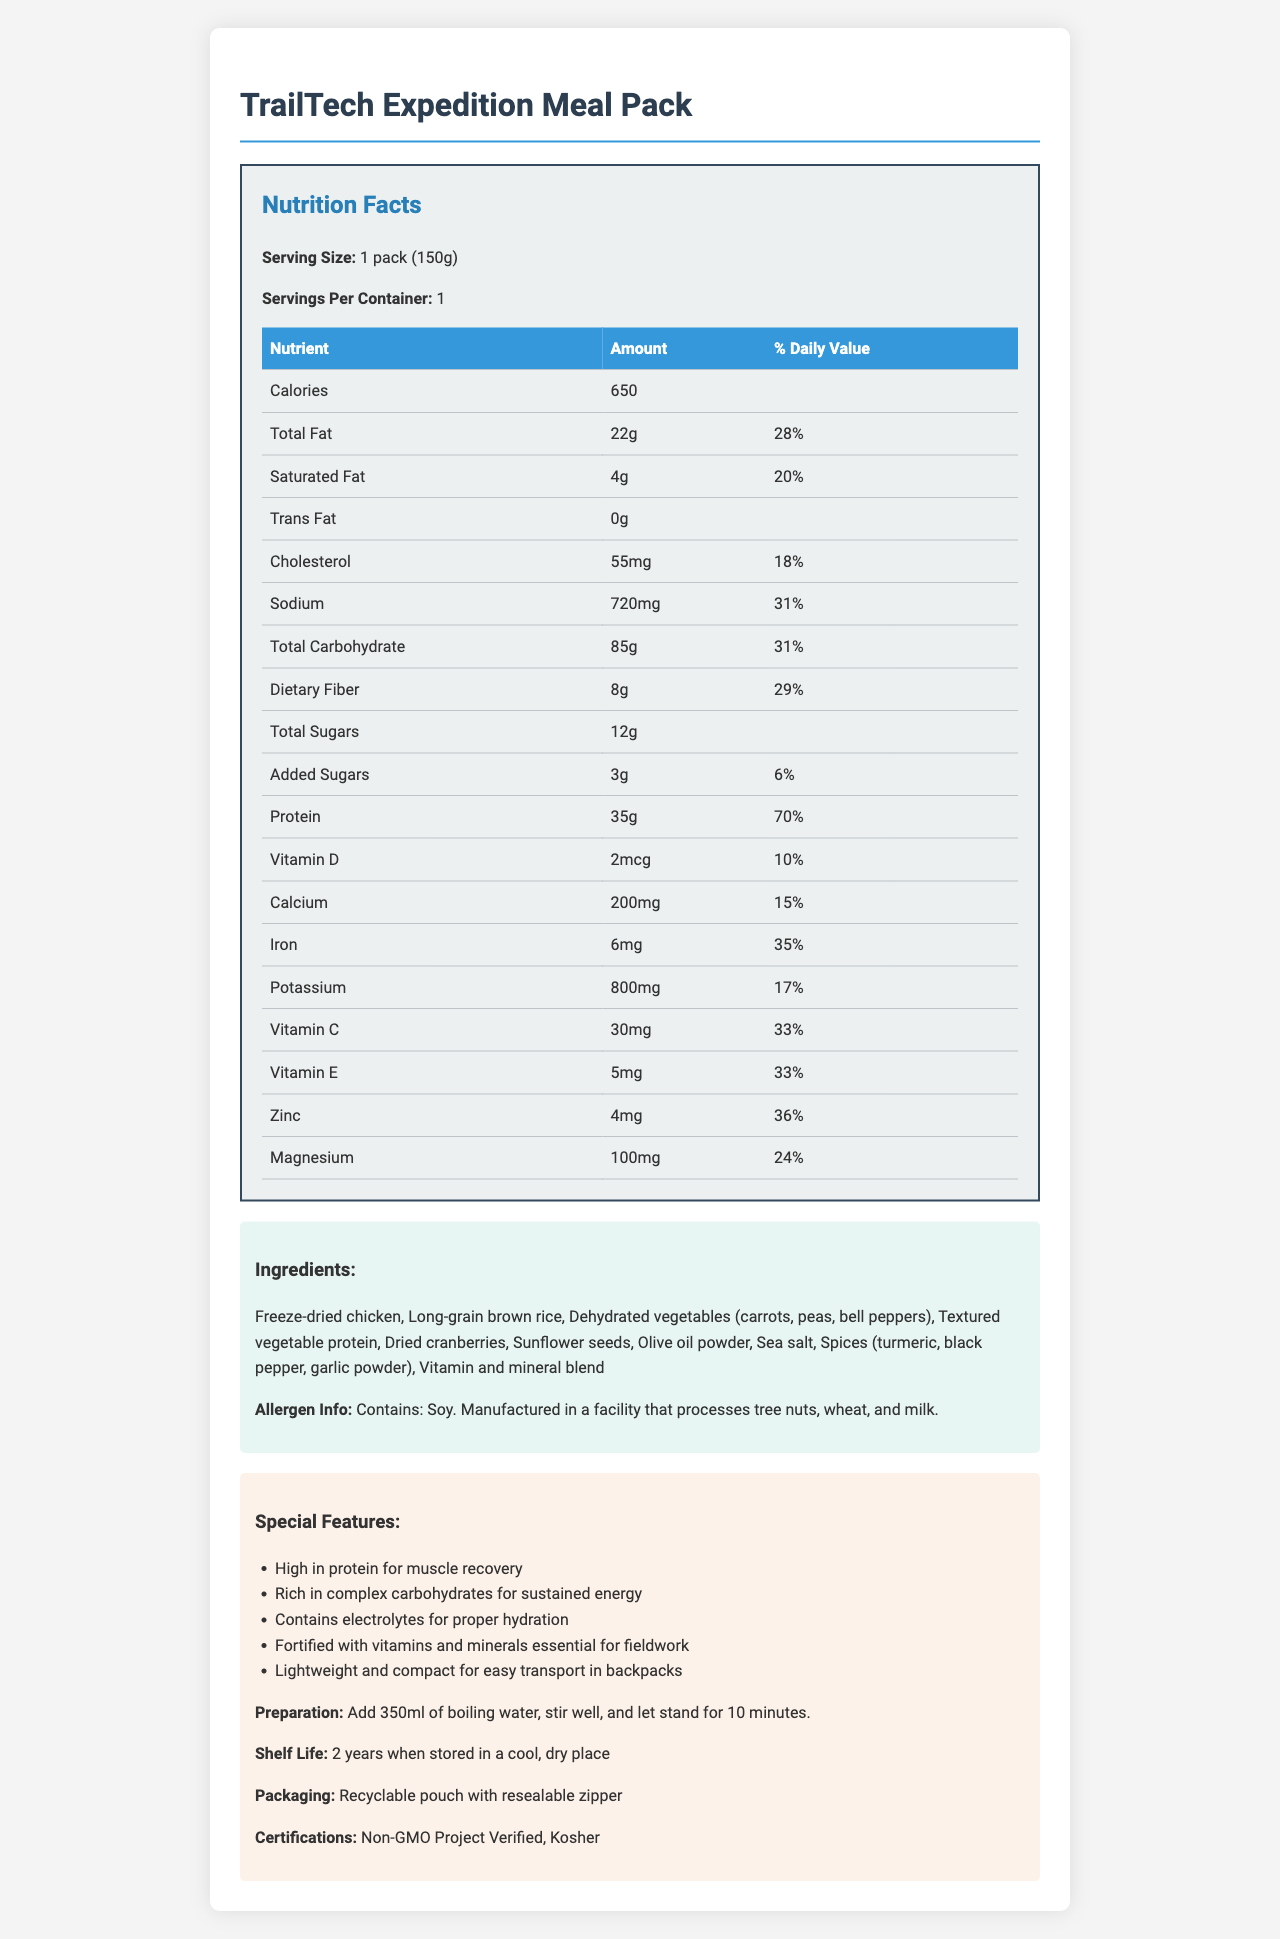what is the serving size of the TrailTech Expedition Meal Pack? The serving size is listed as "1 pack (150g)".
Answer: 1 pack (150g) how much protein does the meal pack provide? According to the nutrition facts, the meal pack contains 35 grams of protein.
Answer: 35g what percentage of daily value for sodium does the meal pack provide? The nutritional label indicates that sodium provides 31% of the daily value.
Answer: 31% what are the main ingredients of the TrailTech Expedition Meal Pack? These ingredients are listed under the ingredients section in the document.
Answer: Freeze-dried chicken, Long-grain brown rice, Dehydrated vegetables (carrots, peas, bell peppers), Textured vegetable protein, Dried cranberries, Sunflower seeds, Olive oil powder, Sea salt, Spices (turmeric, black pepper, garlic powder), Vitamin and mineral blend what is the preparation method for the meal pack? The preparation instructions are provided in the special features section.
Answer: Add 350ml of boiling water, stir well, and let stand for 10 minutes. where is the meal pack manufactured? The document does not provide any information about the manufacturing location.
Answer: Cannot be determined which of the following is a special feature of the meal pack? A. Organic ingredients B. High in protein for muscle recovery C. Gluten-free D. Keto-friendly The special features section mentions that it's high in protein for muscle recovery, but does not indicate organic ingredients, gluten-free, or keto-friendly.
Answer: B how long is the shelf life of the meal pack? The shelf life of the meal pack is indicated as 2 years when stored in a cool, dry place.
Answer: 2 years does the TrailTech Expedition Meal Pack contain any allergens? A. Yes B. No The allergen information section states that it contains soy and is manufactured in a facility that processes tree nuts, wheat, and milk.
Answer: A is the TrailTech Expedition Meal Pack suitable for people with nut allergies? The allergen info states it is manufactured in a facility that processes tree nuts, which poses a risk for those with nut allergies.
Answer: No how many calories are in one serving of the meal pack? The nutrition facts label shows that one serving contains 650 calories.
Answer: 650 summarize the key benefits of the TrailTech Expedition Meal Pack. The meal is formulated for wildlife researchers, providing high protein for muscle recovery, complex carbs for energy, essential nutrients, and convenient packaging for backpacking, with a shelf life of 2 years.
Answer: High-protein content, rich in complex carbohydrates for sustained energy, contains electrolytes, fortified with essential vitamins and minerals, lightweight, compact, and has a long shelf life 